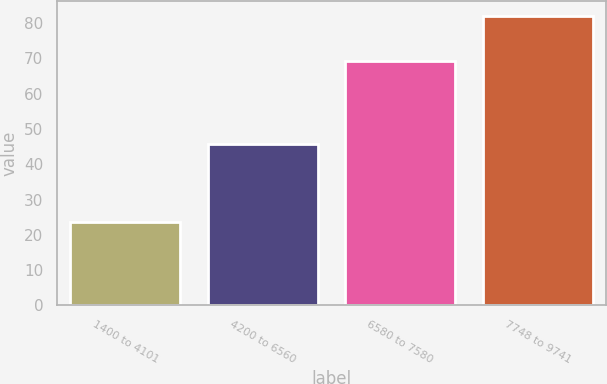<chart> <loc_0><loc_0><loc_500><loc_500><bar_chart><fcel>1400 to 4101<fcel>4200 to 6560<fcel>6580 to 7580<fcel>7748 to 9741<nl><fcel>23.7<fcel>45.79<fcel>69.38<fcel>82.04<nl></chart> 